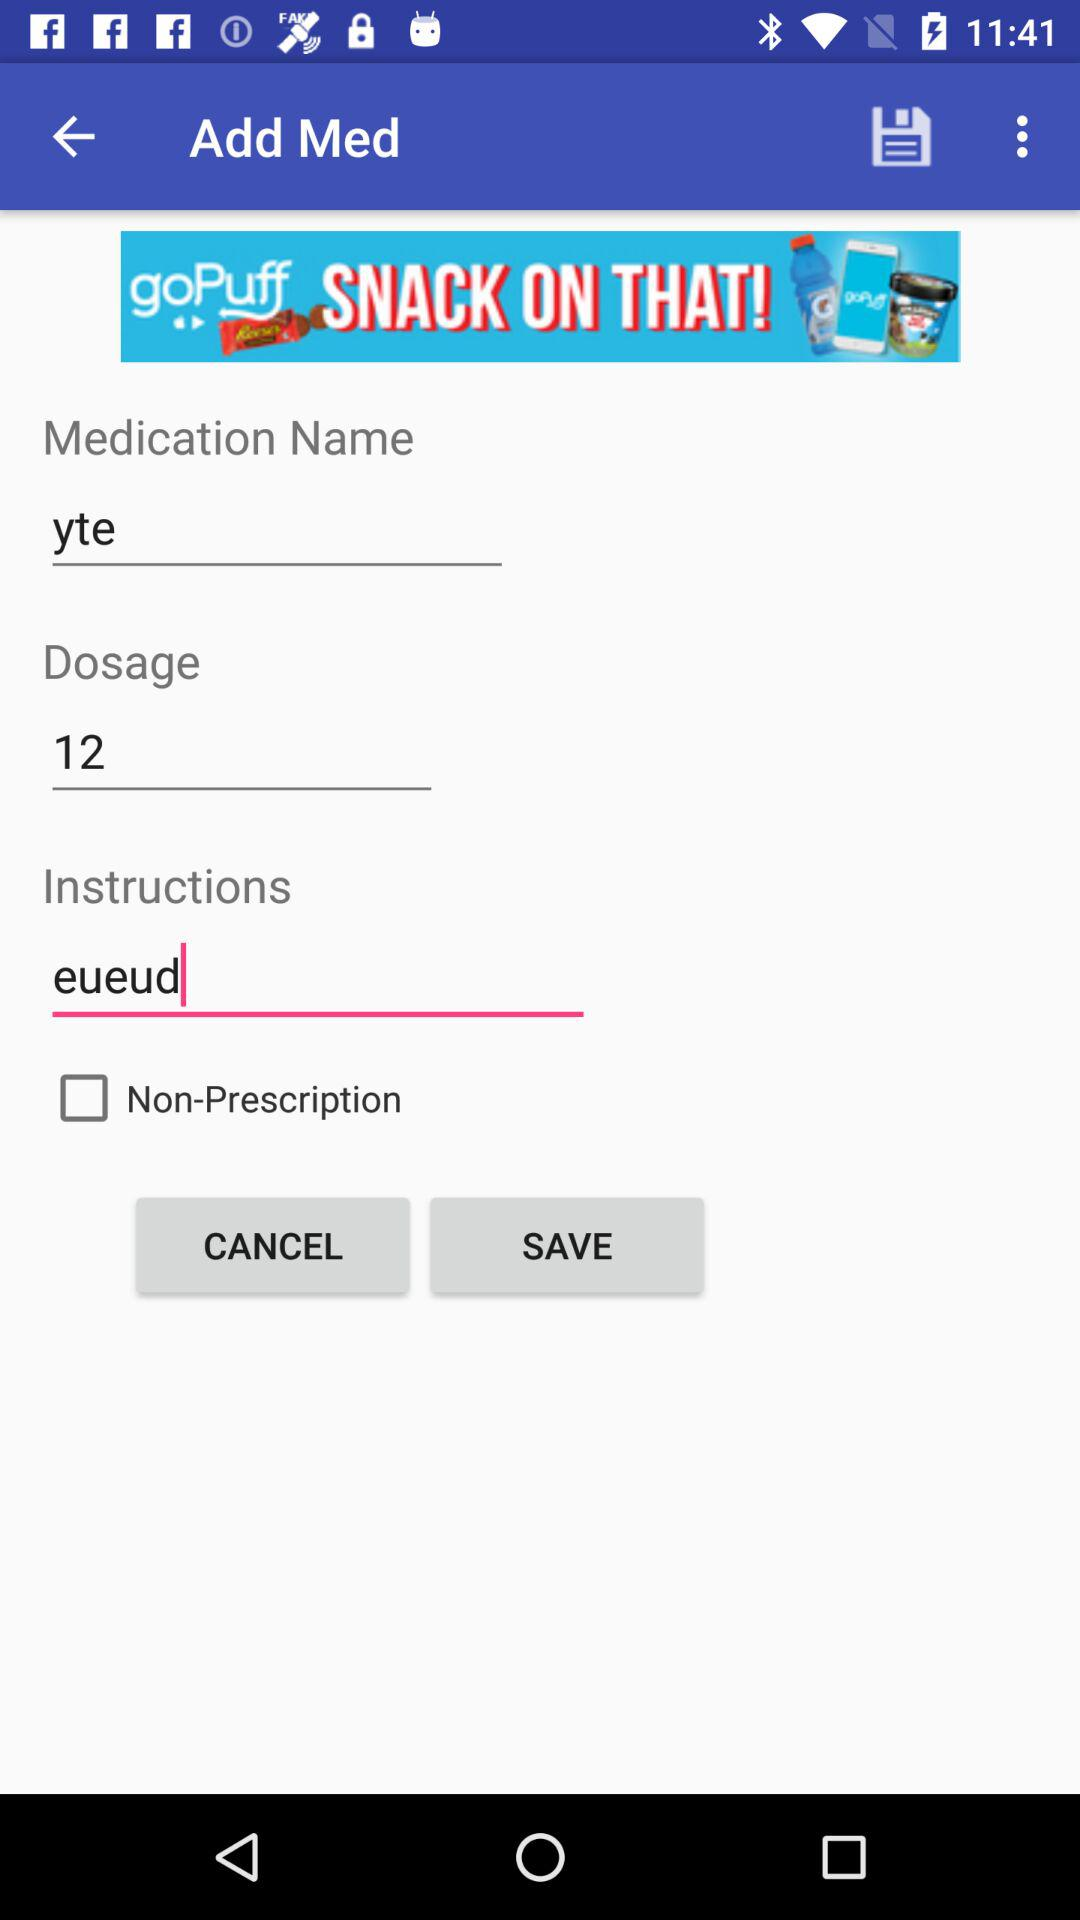What is the "Dosage"? The "Dosage" is 12. 